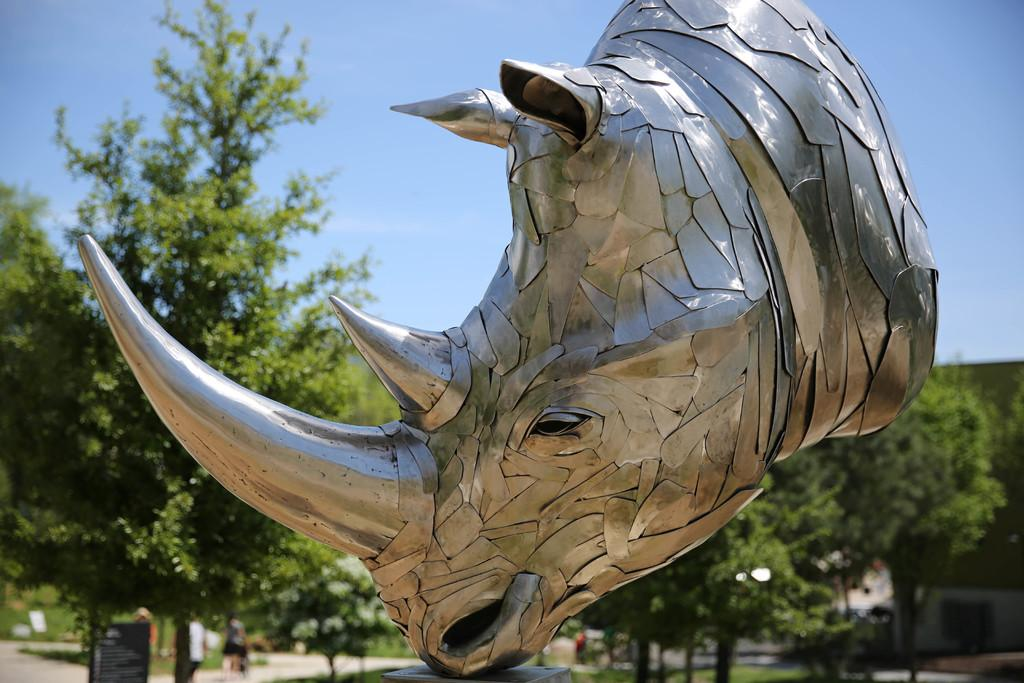What is the main subject of the image? There is a sculpture of an animal's head in the image. What can be seen in the background of the image? There are trees visible behind the sculpture. What type of line is used to draw the grape in the image? There is no grape present in the image, so it is not possible to determine the type of line used to draw it. 